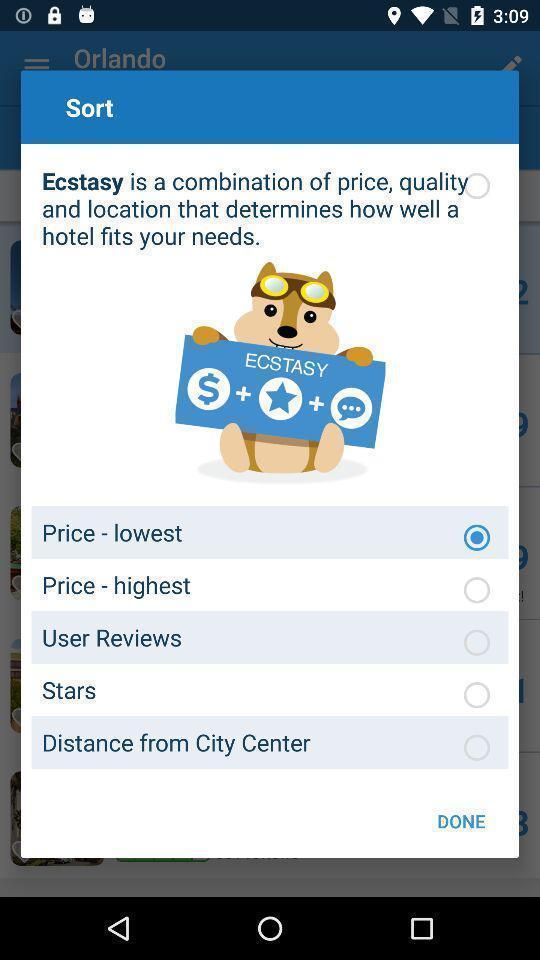What can you discern from this picture? Popup to sort the prices in a travel app. 